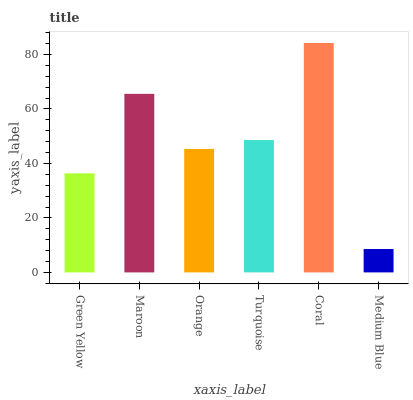Is Medium Blue the minimum?
Answer yes or no. Yes. Is Coral the maximum?
Answer yes or no. Yes. Is Maroon the minimum?
Answer yes or no. No. Is Maroon the maximum?
Answer yes or no. No. Is Maroon greater than Green Yellow?
Answer yes or no. Yes. Is Green Yellow less than Maroon?
Answer yes or no. Yes. Is Green Yellow greater than Maroon?
Answer yes or no. No. Is Maroon less than Green Yellow?
Answer yes or no. No. Is Turquoise the high median?
Answer yes or no. Yes. Is Orange the low median?
Answer yes or no. Yes. Is Medium Blue the high median?
Answer yes or no. No. Is Green Yellow the low median?
Answer yes or no. No. 